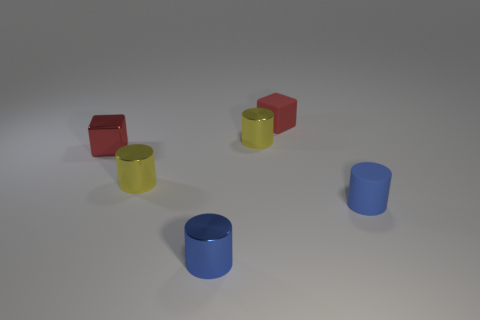What number of tiny cubes are in front of the tiny yellow cylinder that is behind the red metallic block?
Your answer should be very brief. 1. Does the tiny cylinder on the right side of the red rubber cube have the same color as the small metal cube?
Offer a terse response. No. How many objects are either tiny shiny cylinders or small red objects that are in front of the rubber cube?
Give a very brief answer. 4. There is a blue thing to the right of the rubber block; is its shape the same as the tiny matte object that is to the left of the blue matte cylinder?
Your answer should be compact. No. Are there any other things that have the same color as the small matte cylinder?
Ensure brevity in your answer.  Yes. There is a small thing that is both behind the small red metal block and in front of the red rubber object; what material is it?
Ensure brevity in your answer.  Metal. Is the rubber cylinder the same color as the rubber cube?
Offer a very short reply. No. What shape is the small metal object that is the same color as the matte cylinder?
Your answer should be compact. Cylinder. How many small red things have the same shape as the small blue metallic thing?
Ensure brevity in your answer.  0. Do the shiny block and the red matte cube have the same size?
Ensure brevity in your answer.  Yes. 